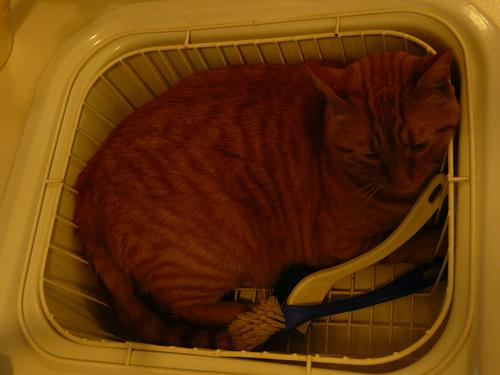Question: what color is the basket?
Choices:
A. White.
B. Orange.
C. Pink.
D. Red.
Answer with the letter. Answer: A Question: what animal is in the photo?
Choices:
A. A kitten.
B. A cat.
C. A dog.
D. A pet.
Answer with the letter. Answer: B 